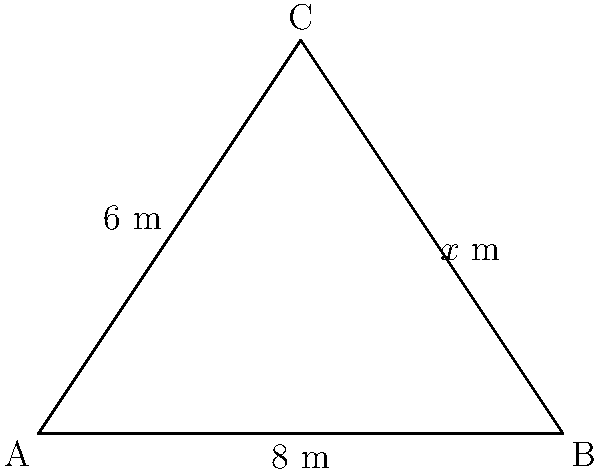For a social experiment on land utilization, you have designated a triangular plot of land. Two sides of the triangle measure 6 meters and 8 meters, respectively, and they form a right angle. If the area of this plot is 24 square meters, what is the length of the third side ($x$) to the nearest tenth of a meter? Let's approach this step-by-step:

1) We know that the area of a triangle is given by the formula: 
   $$\text{Area} = \frac{1}{2} \times \text{base} \times \text{height}$$

2) We're given that the area is 24 square meters, and we can see that the 6m and 8m sides form a right angle. So:
   $$24 = \frac{1}{2} \times 8 \times 6$$

3) This confirms that our given information is consistent.

4) To find the third side, we can use the Pythagorean theorem:
   $$x^2 = 6^2 + 8^2$$

5) Simplifying:
   $$x^2 = 36 + 64 = 100$$

6) Taking the square root of both sides:
   $$x = \sqrt{100} = 10$$

7) Therefore, the length of the third side is 10 meters.

8) Rounding to the nearest tenth (which isn't necessary in this case, but as per the question):
   $$x \approx 10.0 \text{ meters}$$
Answer: 10.0 meters 